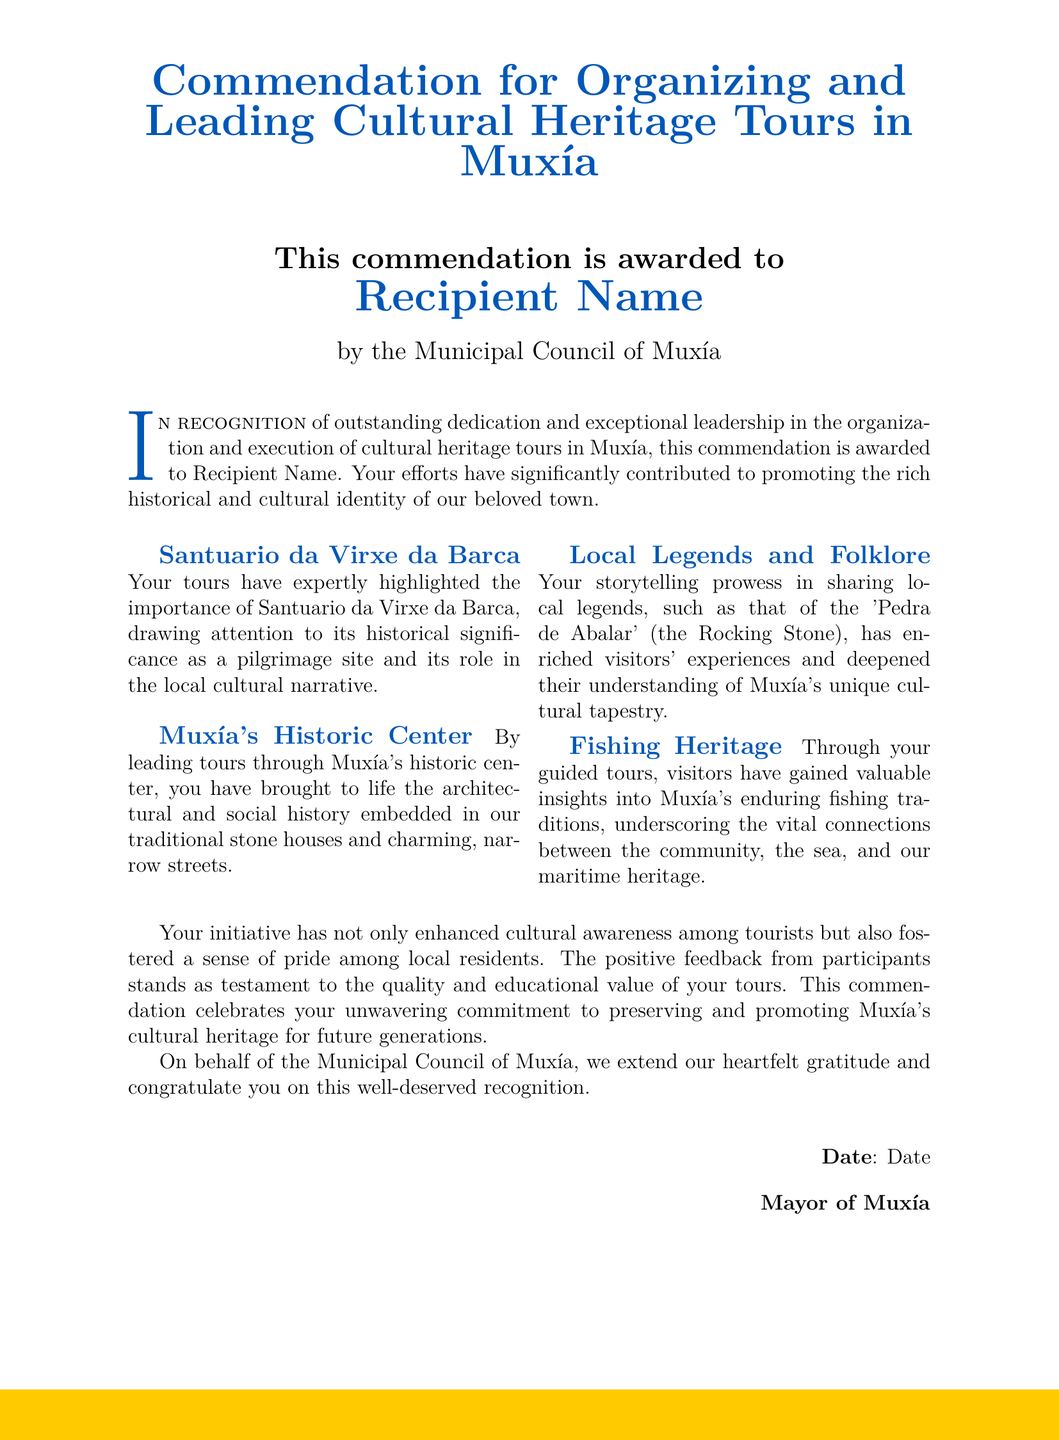What is the title of the document? The title of the document is what describes its purpose and content, which is given at the beginning.
Answer: Commendation for Organizing and Leading Cultural Heritage Tours in Muxía Who is the recipient of the commendation? The document specifies a placeholder for the recipient's name, indicating who is being awarded.
Answer: Recipient Name What is recognized in this commendation? The commendation states what qualities or achievements are acknowledged and celebrated in the document.
Answer: Outstanding dedication and exceptional leadership Which historical site is highlighted in the tours? The document mentions a significant location that is emphasized during the tours in Muxía.
Answer: Santuario da Virxe da Barca What date is mentioned in the document? The document includes a section where the date of the commendation is noted, but it is represented as a placeholder.
Answer: Date What is the role of the Municipal Council in this document? The document indicates the authority responsible for issuing the commendation, which provides context for its significance.
Answer: Awarding body How has the recipient's work impacted local pride? The document describes an effect of the tours on the community, illustrating the broader significance of the recipient's efforts.
Answer: Fostered a sense of pride among local residents Who signed the document? The document identifies the individual in a leadership position who provides formal recognition for the recipient.
Answer: Mayor of Muxía 